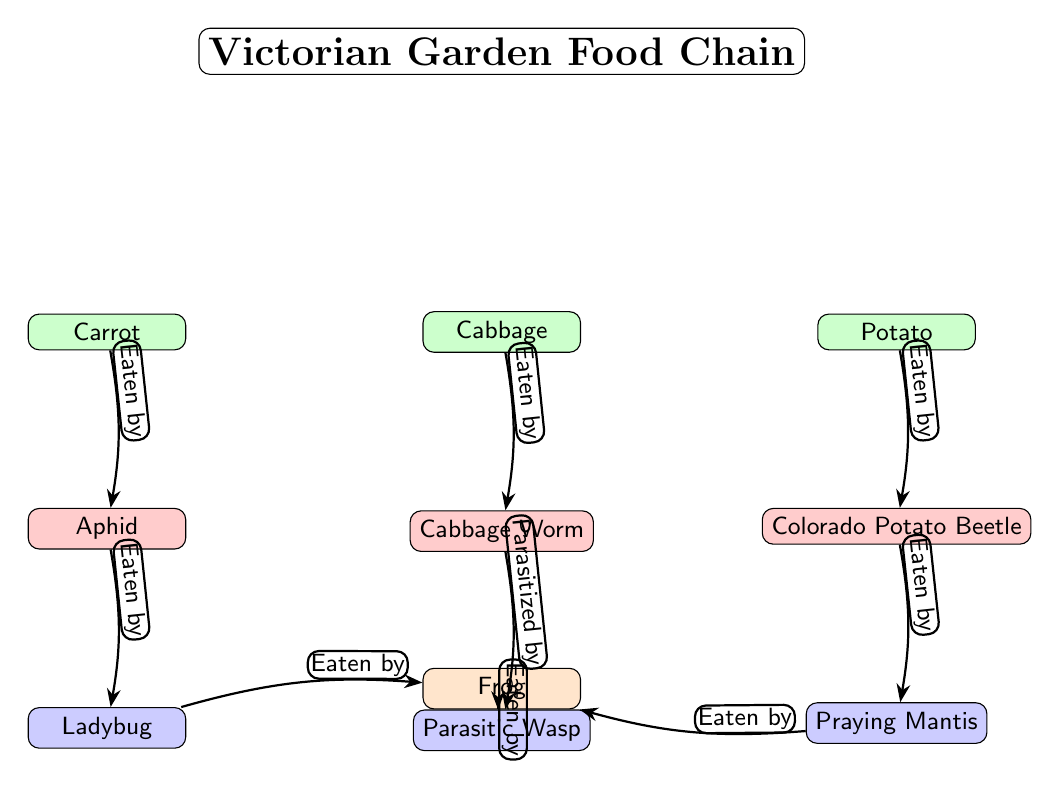What vegetable is eaten by the aphid? In the diagram, the arrow from the carrot points to the aphid with the label "Eaten by," indicating that the carrot is the vegetable consumed by the aphid.
Answer: Carrot How many pests are represented in the diagram? The diagram shows three pests: aphid, cabbage worm, and Colorado potato beetle. By counting these nodes, we find a total of three pests depicted.
Answer: 3 Which beneficial insect is associated with the cabbage worm? According to the diagram, the relationship shows that the cabbage worm is "Parasitized by" the parasitic wasp, indicating that the beneficial insect that interacts with the cabbage worm is the wasp.
Answer: Parasitic Wasp What insect preys on the ladybug? The flow of the diagram shows that the ladybug is eaten by the frog, as indicated by the arrow and label "Eaten by." This implies that the frog is a predator of the ladybug.
Answer: Frog Which vegetable is located furthest to the right in the diagram? Observing the layout of the vegetables in the diagram, the potato is positioned furthest to the right, beyond both the carrot and cabbage.
Answer: Potato What type of insect is the praying mantis? In the diagram, the praying mantis is categorized as a beneficial insect, depicted in blue. This classification designates it as an insect that positively influences the ecosystem in the garden.
Answer: Beneficial insect Which pest is linked to the potato? The diagram indicates that the Colorado potato beetle is associated with the potato, as shown by the arrow labeled "Eaten by" that points from the potato to the beetle.
Answer: Colorado Potato Beetle How many predators are shown in the diagram? There is one predator depicted in the diagram: the frog, which is shown at the bottom. Therefore, this is the only predator represented in the food chain.
Answer: 1 What relationship does the mantis have in the food chain? The mantis is shown to be "Eaten by" the frog, indicating that it is a prey item within this food chain context.
Answer: Eaten by Frog 